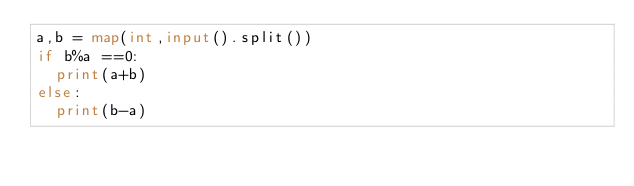<code> <loc_0><loc_0><loc_500><loc_500><_Python_>a,b = map(int,input().split())
if b%a ==0:
  print(a+b)
else:
  print(b-a)</code> 